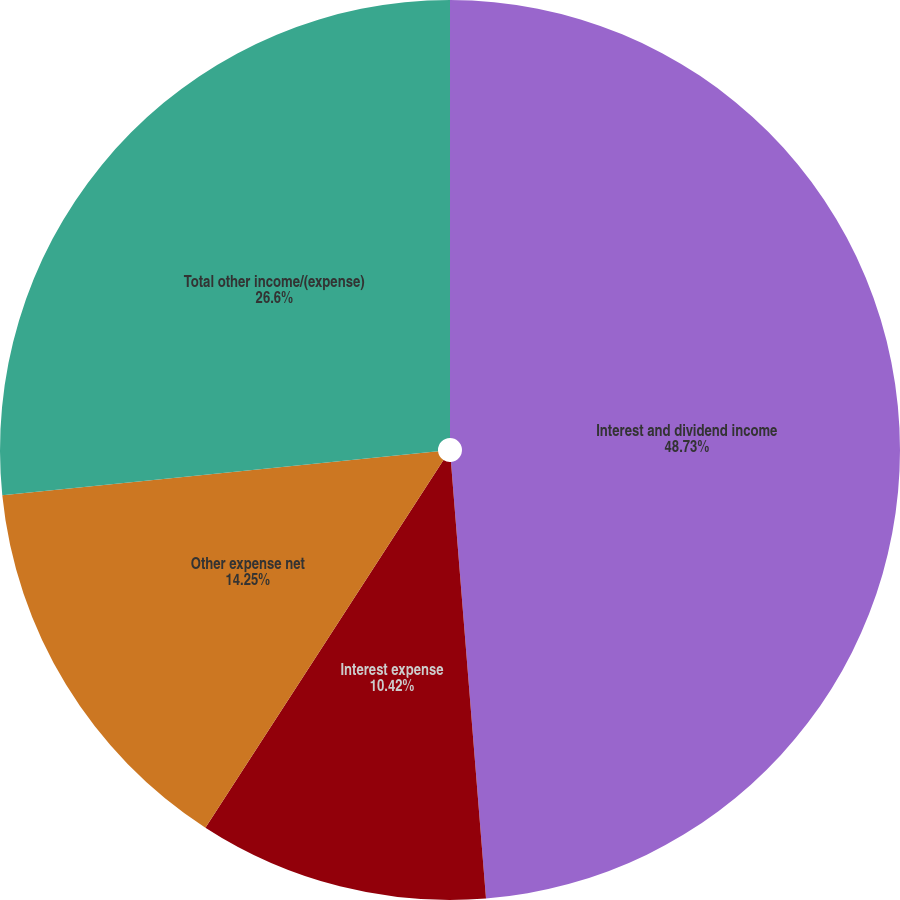<chart> <loc_0><loc_0><loc_500><loc_500><pie_chart><fcel>Interest and dividend income<fcel>Interest expense<fcel>Other expense net<fcel>Total other income/(expense)<nl><fcel>48.72%<fcel>10.42%<fcel>14.25%<fcel>26.6%<nl></chart> 